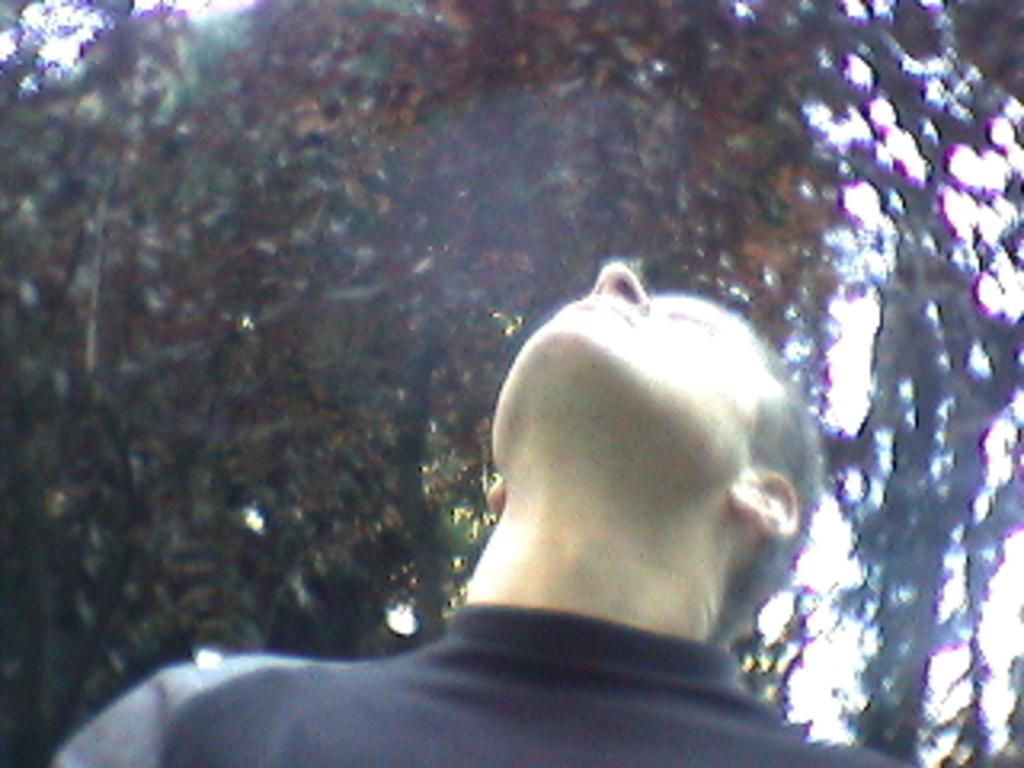What is the main subject in the center of the image? There is a person in the center of the image. What can be seen in the background of the image? There are trees in the background of the image. What idea is the person in the image trying to convey with their copy? There is no indication in the image of the person trying to convey an idea or using a copy. 